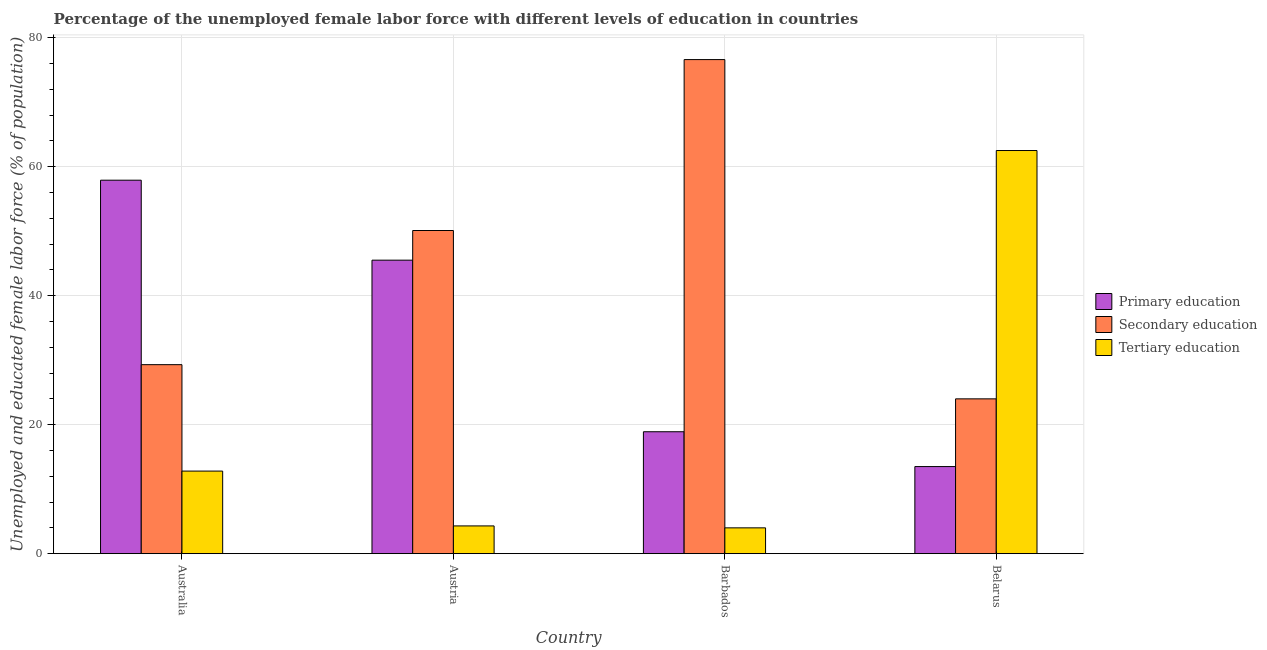How many groups of bars are there?
Offer a terse response. 4. Are the number of bars on each tick of the X-axis equal?
Provide a short and direct response. Yes. What is the percentage of female labor force who received secondary education in Belarus?
Your answer should be very brief. 24. Across all countries, what is the maximum percentage of female labor force who received primary education?
Your answer should be compact. 57.9. Across all countries, what is the minimum percentage of female labor force who received tertiary education?
Provide a succinct answer. 4. In which country was the percentage of female labor force who received secondary education maximum?
Provide a succinct answer. Barbados. In which country was the percentage of female labor force who received primary education minimum?
Keep it short and to the point. Belarus. What is the total percentage of female labor force who received primary education in the graph?
Your response must be concise. 135.8. What is the difference between the percentage of female labor force who received primary education in Austria and that in Barbados?
Your answer should be compact. 26.6. What is the difference between the percentage of female labor force who received secondary education in Austria and the percentage of female labor force who received tertiary education in Barbados?
Keep it short and to the point. 46.1. What is the average percentage of female labor force who received tertiary education per country?
Your answer should be very brief. 20.9. In how many countries, is the percentage of female labor force who received tertiary education greater than 40 %?
Offer a terse response. 1. What is the ratio of the percentage of female labor force who received primary education in Australia to that in Barbados?
Offer a very short reply. 3.06. Is the percentage of female labor force who received primary education in Australia less than that in Belarus?
Your answer should be very brief. No. Is the difference between the percentage of female labor force who received secondary education in Austria and Barbados greater than the difference between the percentage of female labor force who received primary education in Austria and Barbados?
Offer a terse response. No. What is the difference between the highest and the second highest percentage of female labor force who received primary education?
Offer a very short reply. 12.4. What is the difference between the highest and the lowest percentage of female labor force who received primary education?
Your answer should be compact. 44.4. In how many countries, is the percentage of female labor force who received secondary education greater than the average percentage of female labor force who received secondary education taken over all countries?
Ensure brevity in your answer.  2. Is the sum of the percentage of female labor force who received secondary education in Austria and Barbados greater than the maximum percentage of female labor force who received tertiary education across all countries?
Provide a short and direct response. Yes. What does the 2nd bar from the left in Australia represents?
Your answer should be very brief. Secondary education. What does the 3rd bar from the right in Belarus represents?
Keep it short and to the point. Primary education. Is it the case that in every country, the sum of the percentage of female labor force who received primary education and percentage of female labor force who received secondary education is greater than the percentage of female labor force who received tertiary education?
Offer a very short reply. No. How many bars are there?
Provide a short and direct response. 12. How many countries are there in the graph?
Ensure brevity in your answer.  4. Are the values on the major ticks of Y-axis written in scientific E-notation?
Your response must be concise. No. Does the graph contain any zero values?
Your answer should be very brief. No. Does the graph contain grids?
Your response must be concise. Yes. Where does the legend appear in the graph?
Your response must be concise. Center right. How are the legend labels stacked?
Make the answer very short. Vertical. What is the title of the graph?
Offer a terse response. Percentage of the unemployed female labor force with different levels of education in countries. What is the label or title of the X-axis?
Your answer should be very brief. Country. What is the label or title of the Y-axis?
Give a very brief answer. Unemployed and educated female labor force (% of population). What is the Unemployed and educated female labor force (% of population) of Primary education in Australia?
Provide a succinct answer. 57.9. What is the Unemployed and educated female labor force (% of population) in Secondary education in Australia?
Your answer should be very brief. 29.3. What is the Unemployed and educated female labor force (% of population) of Tertiary education in Australia?
Keep it short and to the point. 12.8. What is the Unemployed and educated female labor force (% of population) in Primary education in Austria?
Your answer should be very brief. 45.5. What is the Unemployed and educated female labor force (% of population) in Secondary education in Austria?
Provide a short and direct response. 50.1. What is the Unemployed and educated female labor force (% of population) in Tertiary education in Austria?
Ensure brevity in your answer.  4.3. What is the Unemployed and educated female labor force (% of population) in Primary education in Barbados?
Provide a succinct answer. 18.9. What is the Unemployed and educated female labor force (% of population) of Secondary education in Barbados?
Provide a short and direct response. 76.6. What is the Unemployed and educated female labor force (% of population) of Primary education in Belarus?
Make the answer very short. 13.5. What is the Unemployed and educated female labor force (% of population) in Tertiary education in Belarus?
Provide a short and direct response. 62.5. Across all countries, what is the maximum Unemployed and educated female labor force (% of population) in Primary education?
Give a very brief answer. 57.9. Across all countries, what is the maximum Unemployed and educated female labor force (% of population) of Secondary education?
Make the answer very short. 76.6. Across all countries, what is the maximum Unemployed and educated female labor force (% of population) of Tertiary education?
Keep it short and to the point. 62.5. Across all countries, what is the minimum Unemployed and educated female labor force (% of population) of Primary education?
Keep it short and to the point. 13.5. Across all countries, what is the minimum Unemployed and educated female labor force (% of population) of Secondary education?
Provide a succinct answer. 24. Across all countries, what is the minimum Unemployed and educated female labor force (% of population) in Tertiary education?
Make the answer very short. 4. What is the total Unemployed and educated female labor force (% of population) in Primary education in the graph?
Your answer should be compact. 135.8. What is the total Unemployed and educated female labor force (% of population) in Secondary education in the graph?
Your answer should be very brief. 180. What is the total Unemployed and educated female labor force (% of population) in Tertiary education in the graph?
Your answer should be very brief. 83.6. What is the difference between the Unemployed and educated female labor force (% of population) of Secondary education in Australia and that in Austria?
Your answer should be very brief. -20.8. What is the difference between the Unemployed and educated female labor force (% of population) in Tertiary education in Australia and that in Austria?
Make the answer very short. 8.5. What is the difference between the Unemployed and educated female labor force (% of population) of Secondary education in Australia and that in Barbados?
Provide a short and direct response. -47.3. What is the difference between the Unemployed and educated female labor force (% of population) of Tertiary education in Australia and that in Barbados?
Provide a short and direct response. 8.8. What is the difference between the Unemployed and educated female labor force (% of population) of Primary education in Australia and that in Belarus?
Give a very brief answer. 44.4. What is the difference between the Unemployed and educated female labor force (% of population) in Tertiary education in Australia and that in Belarus?
Provide a short and direct response. -49.7. What is the difference between the Unemployed and educated female labor force (% of population) of Primary education in Austria and that in Barbados?
Your answer should be compact. 26.6. What is the difference between the Unemployed and educated female labor force (% of population) in Secondary education in Austria and that in Barbados?
Provide a short and direct response. -26.5. What is the difference between the Unemployed and educated female labor force (% of population) of Secondary education in Austria and that in Belarus?
Provide a short and direct response. 26.1. What is the difference between the Unemployed and educated female labor force (% of population) of Tertiary education in Austria and that in Belarus?
Offer a terse response. -58.2. What is the difference between the Unemployed and educated female labor force (% of population) in Secondary education in Barbados and that in Belarus?
Offer a very short reply. 52.6. What is the difference between the Unemployed and educated female labor force (% of population) in Tertiary education in Barbados and that in Belarus?
Your answer should be very brief. -58.5. What is the difference between the Unemployed and educated female labor force (% of population) of Primary education in Australia and the Unemployed and educated female labor force (% of population) of Secondary education in Austria?
Make the answer very short. 7.8. What is the difference between the Unemployed and educated female labor force (% of population) in Primary education in Australia and the Unemployed and educated female labor force (% of population) in Tertiary education in Austria?
Provide a short and direct response. 53.6. What is the difference between the Unemployed and educated female labor force (% of population) of Primary education in Australia and the Unemployed and educated female labor force (% of population) of Secondary education in Barbados?
Your response must be concise. -18.7. What is the difference between the Unemployed and educated female labor force (% of population) of Primary education in Australia and the Unemployed and educated female labor force (% of population) of Tertiary education in Barbados?
Give a very brief answer. 53.9. What is the difference between the Unemployed and educated female labor force (% of population) in Secondary education in Australia and the Unemployed and educated female labor force (% of population) in Tertiary education in Barbados?
Make the answer very short. 25.3. What is the difference between the Unemployed and educated female labor force (% of population) in Primary education in Australia and the Unemployed and educated female labor force (% of population) in Secondary education in Belarus?
Provide a succinct answer. 33.9. What is the difference between the Unemployed and educated female labor force (% of population) of Primary education in Australia and the Unemployed and educated female labor force (% of population) of Tertiary education in Belarus?
Keep it short and to the point. -4.6. What is the difference between the Unemployed and educated female labor force (% of population) of Secondary education in Australia and the Unemployed and educated female labor force (% of population) of Tertiary education in Belarus?
Your answer should be very brief. -33.2. What is the difference between the Unemployed and educated female labor force (% of population) of Primary education in Austria and the Unemployed and educated female labor force (% of population) of Secondary education in Barbados?
Your answer should be very brief. -31.1. What is the difference between the Unemployed and educated female labor force (% of population) of Primary education in Austria and the Unemployed and educated female labor force (% of population) of Tertiary education in Barbados?
Your answer should be compact. 41.5. What is the difference between the Unemployed and educated female labor force (% of population) in Secondary education in Austria and the Unemployed and educated female labor force (% of population) in Tertiary education in Barbados?
Provide a succinct answer. 46.1. What is the difference between the Unemployed and educated female labor force (% of population) of Primary education in Austria and the Unemployed and educated female labor force (% of population) of Secondary education in Belarus?
Offer a very short reply. 21.5. What is the difference between the Unemployed and educated female labor force (% of population) in Primary education in Austria and the Unemployed and educated female labor force (% of population) in Tertiary education in Belarus?
Your response must be concise. -17. What is the difference between the Unemployed and educated female labor force (% of population) in Primary education in Barbados and the Unemployed and educated female labor force (% of population) in Tertiary education in Belarus?
Your answer should be very brief. -43.6. What is the difference between the Unemployed and educated female labor force (% of population) in Secondary education in Barbados and the Unemployed and educated female labor force (% of population) in Tertiary education in Belarus?
Offer a terse response. 14.1. What is the average Unemployed and educated female labor force (% of population) in Primary education per country?
Your answer should be compact. 33.95. What is the average Unemployed and educated female labor force (% of population) of Secondary education per country?
Offer a terse response. 45. What is the average Unemployed and educated female labor force (% of population) in Tertiary education per country?
Make the answer very short. 20.9. What is the difference between the Unemployed and educated female labor force (% of population) of Primary education and Unemployed and educated female labor force (% of population) of Secondary education in Australia?
Your answer should be very brief. 28.6. What is the difference between the Unemployed and educated female labor force (% of population) of Primary education and Unemployed and educated female labor force (% of population) of Tertiary education in Australia?
Provide a short and direct response. 45.1. What is the difference between the Unemployed and educated female labor force (% of population) in Primary education and Unemployed and educated female labor force (% of population) in Secondary education in Austria?
Provide a succinct answer. -4.6. What is the difference between the Unemployed and educated female labor force (% of population) of Primary education and Unemployed and educated female labor force (% of population) of Tertiary education in Austria?
Your response must be concise. 41.2. What is the difference between the Unemployed and educated female labor force (% of population) in Secondary education and Unemployed and educated female labor force (% of population) in Tertiary education in Austria?
Ensure brevity in your answer.  45.8. What is the difference between the Unemployed and educated female labor force (% of population) in Primary education and Unemployed and educated female labor force (% of population) in Secondary education in Barbados?
Provide a succinct answer. -57.7. What is the difference between the Unemployed and educated female labor force (% of population) of Primary education and Unemployed and educated female labor force (% of population) of Tertiary education in Barbados?
Your answer should be very brief. 14.9. What is the difference between the Unemployed and educated female labor force (% of population) in Secondary education and Unemployed and educated female labor force (% of population) in Tertiary education in Barbados?
Your answer should be very brief. 72.6. What is the difference between the Unemployed and educated female labor force (% of population) of Primary education and Unemployed and educated female labor force (% of population) of Secondary education in Belarus?
Keep it short and to the point. -10.5. What is the difference between the Unemployed and educated female labor force (% of population) in Primary education and Unemployed and educated female labor force (% of population) in Tertiary education in Belarus?
Your answer should be very brief. -49. What is the difference between the Unemployed and educated female labor force (% of population) of Secondary education and Unemployed and educated female labor force (% of population) of Tertiary education in Belarus?
Make the answer very short. -38.5. What is the ratio of the Unemployed and educated female labor force (% of population) in Primary education in Australia to that in Austria?
Your response must be concise. 1.27. What is the ratio of the Unemployed and educated female labor force (% of population) of Secondary education in Australia to that in Austria?
Your response must be concise. 0.58. What is the ratio of the Unemployed and educated female labor force (% of population) in Tertiary education in Australia to that in Austria?
Offer a very short reply. 2.98. What is the ratio of the Unemployed and educated female labor force (% of population) in Primary education in Australia to that in Barbados?
Ensure brevity in your answer.  3.06. What is the ratio of the Unemployed and educated female labor force (% of population) of Secondary education in Australia to that in Barbados?
Your response must be concise. 0.38. What is the ratio of the Unemployed and educated female labor force (% of population) in Tertiary education in Australia to that in Barbados?
Offer a very short reply. 3.2. What is the ratio of the Unemployed and educated female labor force (% of population) of Primary education in Australia to that in Belarus?
Ensure brevity in your answer.  4.29. What is the ratio of the Unemployed and educated female labor force (% of population) of Secondary education in Australia to that in Belarus?
Provide a short and direct response. 1.22. What is the ratio of the Unemployed and educated female labor force (% of population) in Tertiary education in Australia to that in Belarus?
Provide a succinct answer. 0.2. What is the ratio of the Unemployed and educated female labor force (% of population) in Primary education in Austria to that in Barbados?
Give a very brief answer. 2.41. What is the ratio of the Unemployed and educated female labor force (% of population) in Secondary education in Austria to that in Barbados?
Offer a very short reply. 0.65. What is the ratio of the Unemployed and educated female labor force (% of population) in Tertiary education in Austria to that in Barbados?
Your response must be concise. 1.07. What is the ratio of the Unemployed and educated female labor force (% of population) in Primary education in Austria to that in Belarus?
Your answer should be very brief. 3.37. What is the ratio of the Unemployed and educated female labor force (% of population) of Secondary education in Austria to that in Belarus?
Ensure brevity in your answer.  2.09. What is the ratio of the Unemployed and educated female labor force (% of population) in Tertiary education in Austria to that in Belarus?
Ensure brevity in your answer.  0.07. What is the ratio of the Unemployed and educated female labor force (% of population) in Secondary education in Barbados to that in Belarus?
Provide a short and direct response. 3.19. What is the ratio of the Unemployed and educated female labor force (% of population) in Tertiary education in Barbados to that in Belarus?
Give a very brief answer. 0.06. What is the difference between the highest and the second highest Unemployed and educated female labor force (% of population) in Tertiary education?
Offer a very short reply. 49.7. What is the difference between the highest and the lowest Unemployed and educated female labor force (% of population) in Primary education?
Offer a very short reply. 44.4. What is the difference between the highest and the lowest Unemployed and educated female labor force (% of population) in Secondary education?
Ensure brevity in your answer.  52.6. What is the difference between the highest and the lowest Unemployed and educated female labor force (% of population) of Tertiary education?
Provide a succinct answer. 58.5. 